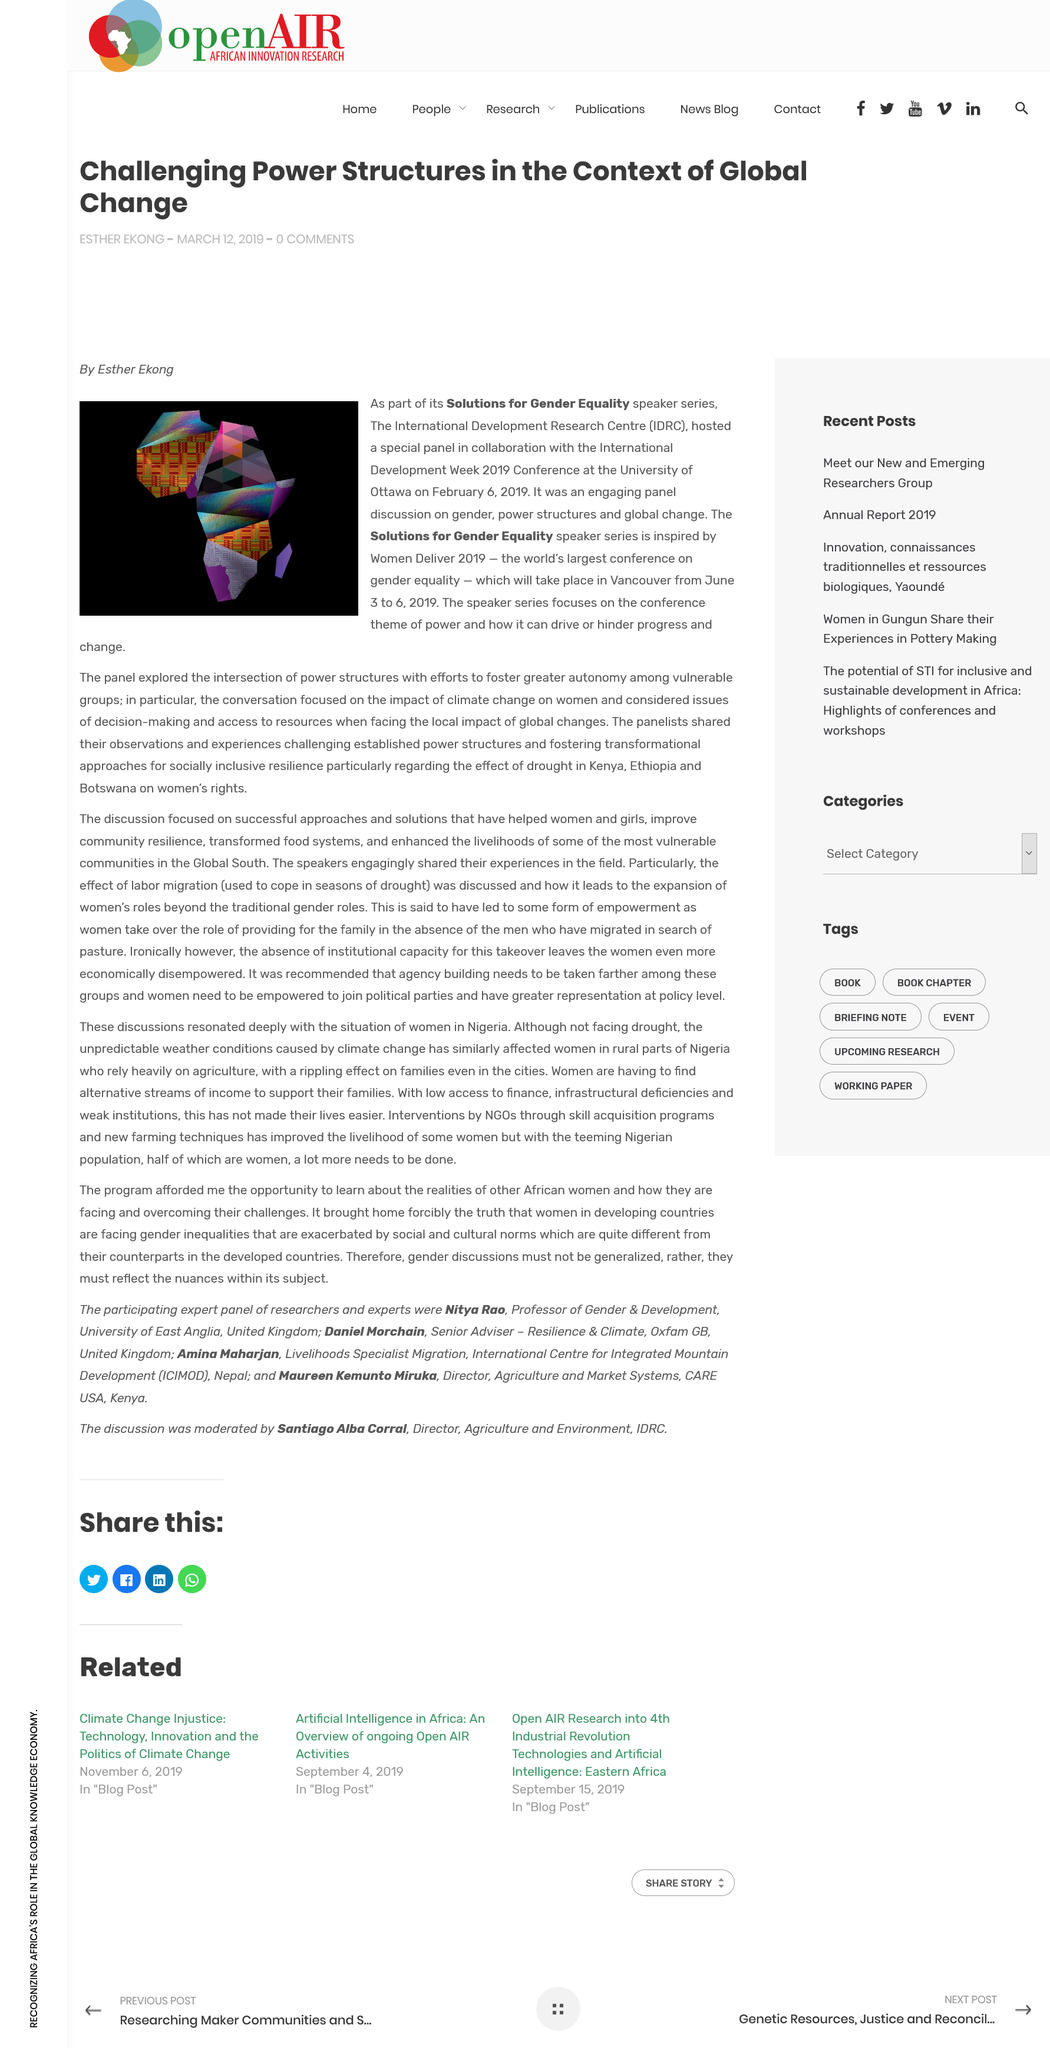Draw attention to some important aspects in this diagram. Women Deliver 2019 is the largest conference in the world focused on gender equality. The International Development Week 2019 Conference featured a panel discussion on the topic of gender and power structures in the context of global change, during which the panel explored the ways in which gender affects power dynamics and the impact of global change on these dynamics. Women Deliver 2019 took place from June 3-6, 2019. 